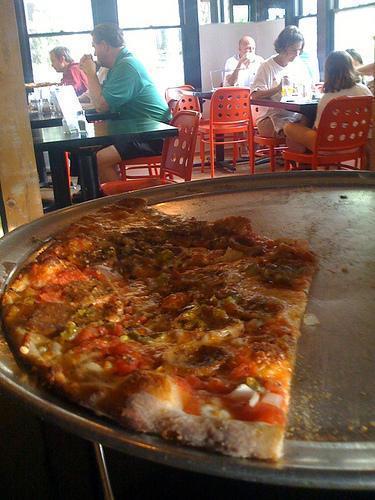What category of pizza would this fall into?
Make your selection and explain in format: 'Answer: answer
Rationale: rationale.'
Options: Cheese only, hawaiian, vegetarian, gluten-free. Answer: vegetarian.
Rationale: It looks like it is covered in assorted veggies. 